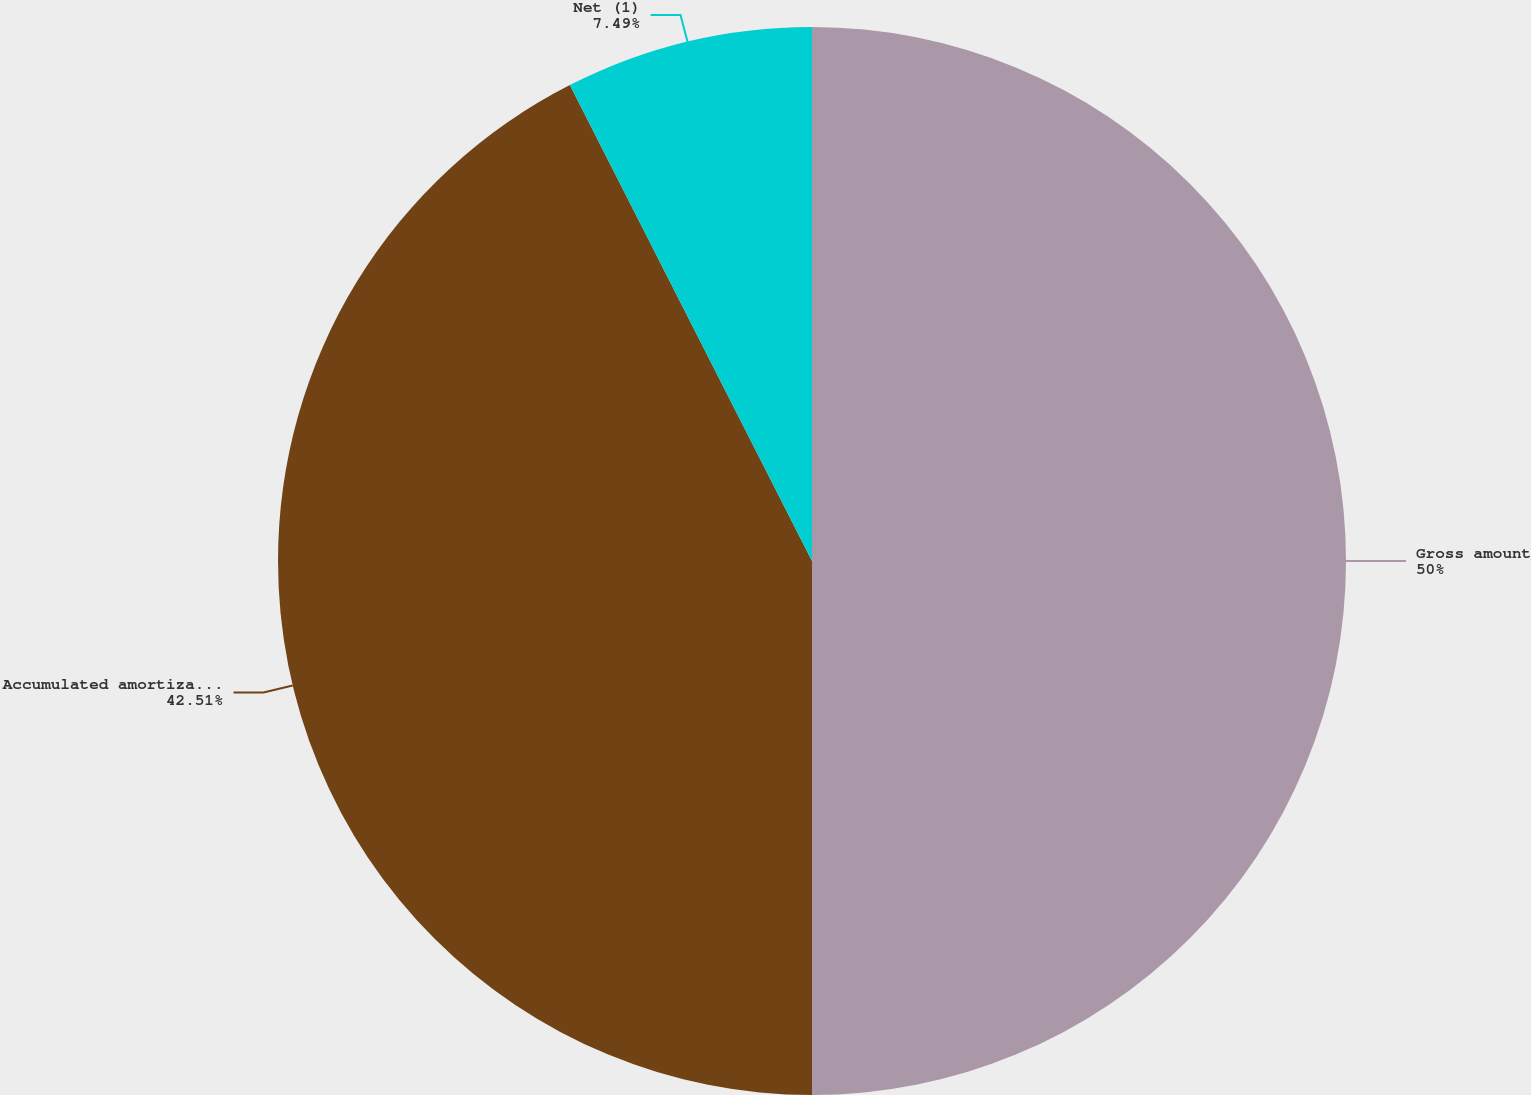Convert chart to OTSL. <chart><loc_0><loc_0><loc_500><loc_500><pie_chart><fcel>Gross amount<fcel>Accumulated amortization<fcel>Net (1)<nl><fcel>50.0%<fcel>42.51%<fcel>7.49%<nl></chart> 